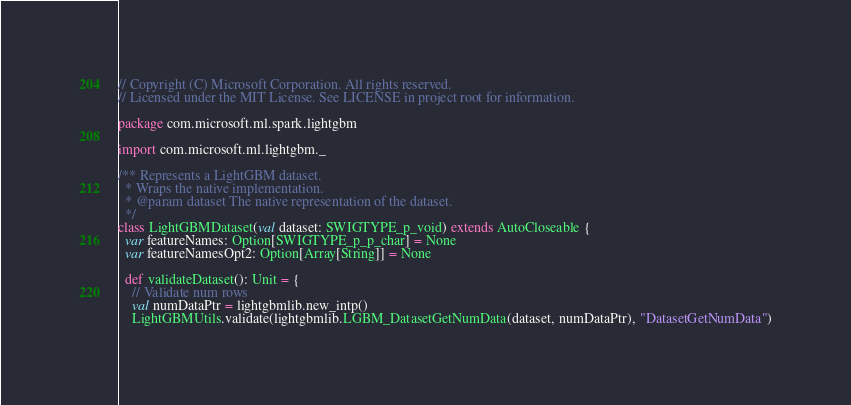<code> <loc_0><loc_0><loc_500><loc_500><_Scala_>// Copyright (C) Microsoft Corporation. All rights reserved.
// Licensed under the MIT License. See LICENSE in project root for information.

package com.microsoft.ml.spark.lightgbm

import com.microsoft.ml.lightgbm._

/** Represents a LightGBM dataset.
  * Wraps the native implementation.
  * @param dataset The native representation of the dataset.
  */
class LightGBMDataset(val dataset: SWIGTYPE_p_void) extends AutoCloseable {
  var featureNames: Option[SWIGTYPE_p_p_char] = None
  var featureNamesOpt2: Option[Array[String]] = None

  def validateDataset(): Unit = {
    // Validate num rows
    val numDataPtr = lightgbmlib.new_intp()
    LightGBMUtils.validate(lightgbmlib.LGBM_DatasetGetNumData(dataset, numDataPtr), "DatasetGetNumData")</code> 